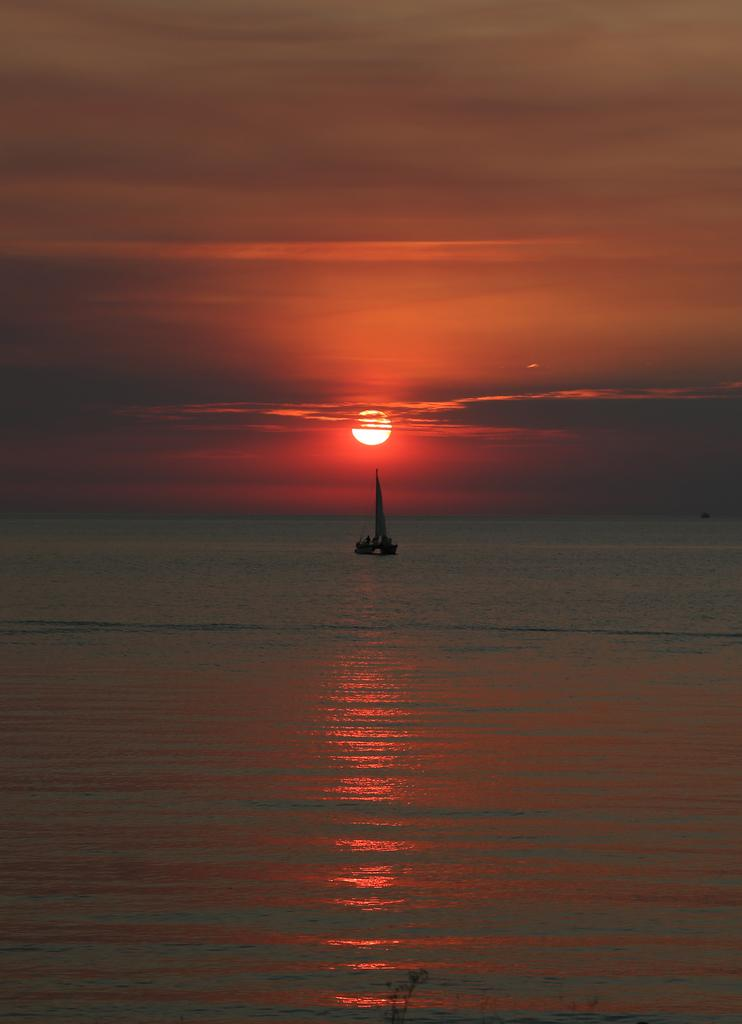What is the main subject of the image? The main subject of the image is a boat. Where is the boat located? The boat is on the water. What can be seen in the sky in the background of the image? There are clouds and the sun visible in the sky in the background. What type of goose can be seen sleeping in the bedroom in the image? There is no goose or bedroom present in the image; it features a boat on the water with clouds and the sun in the sky. 